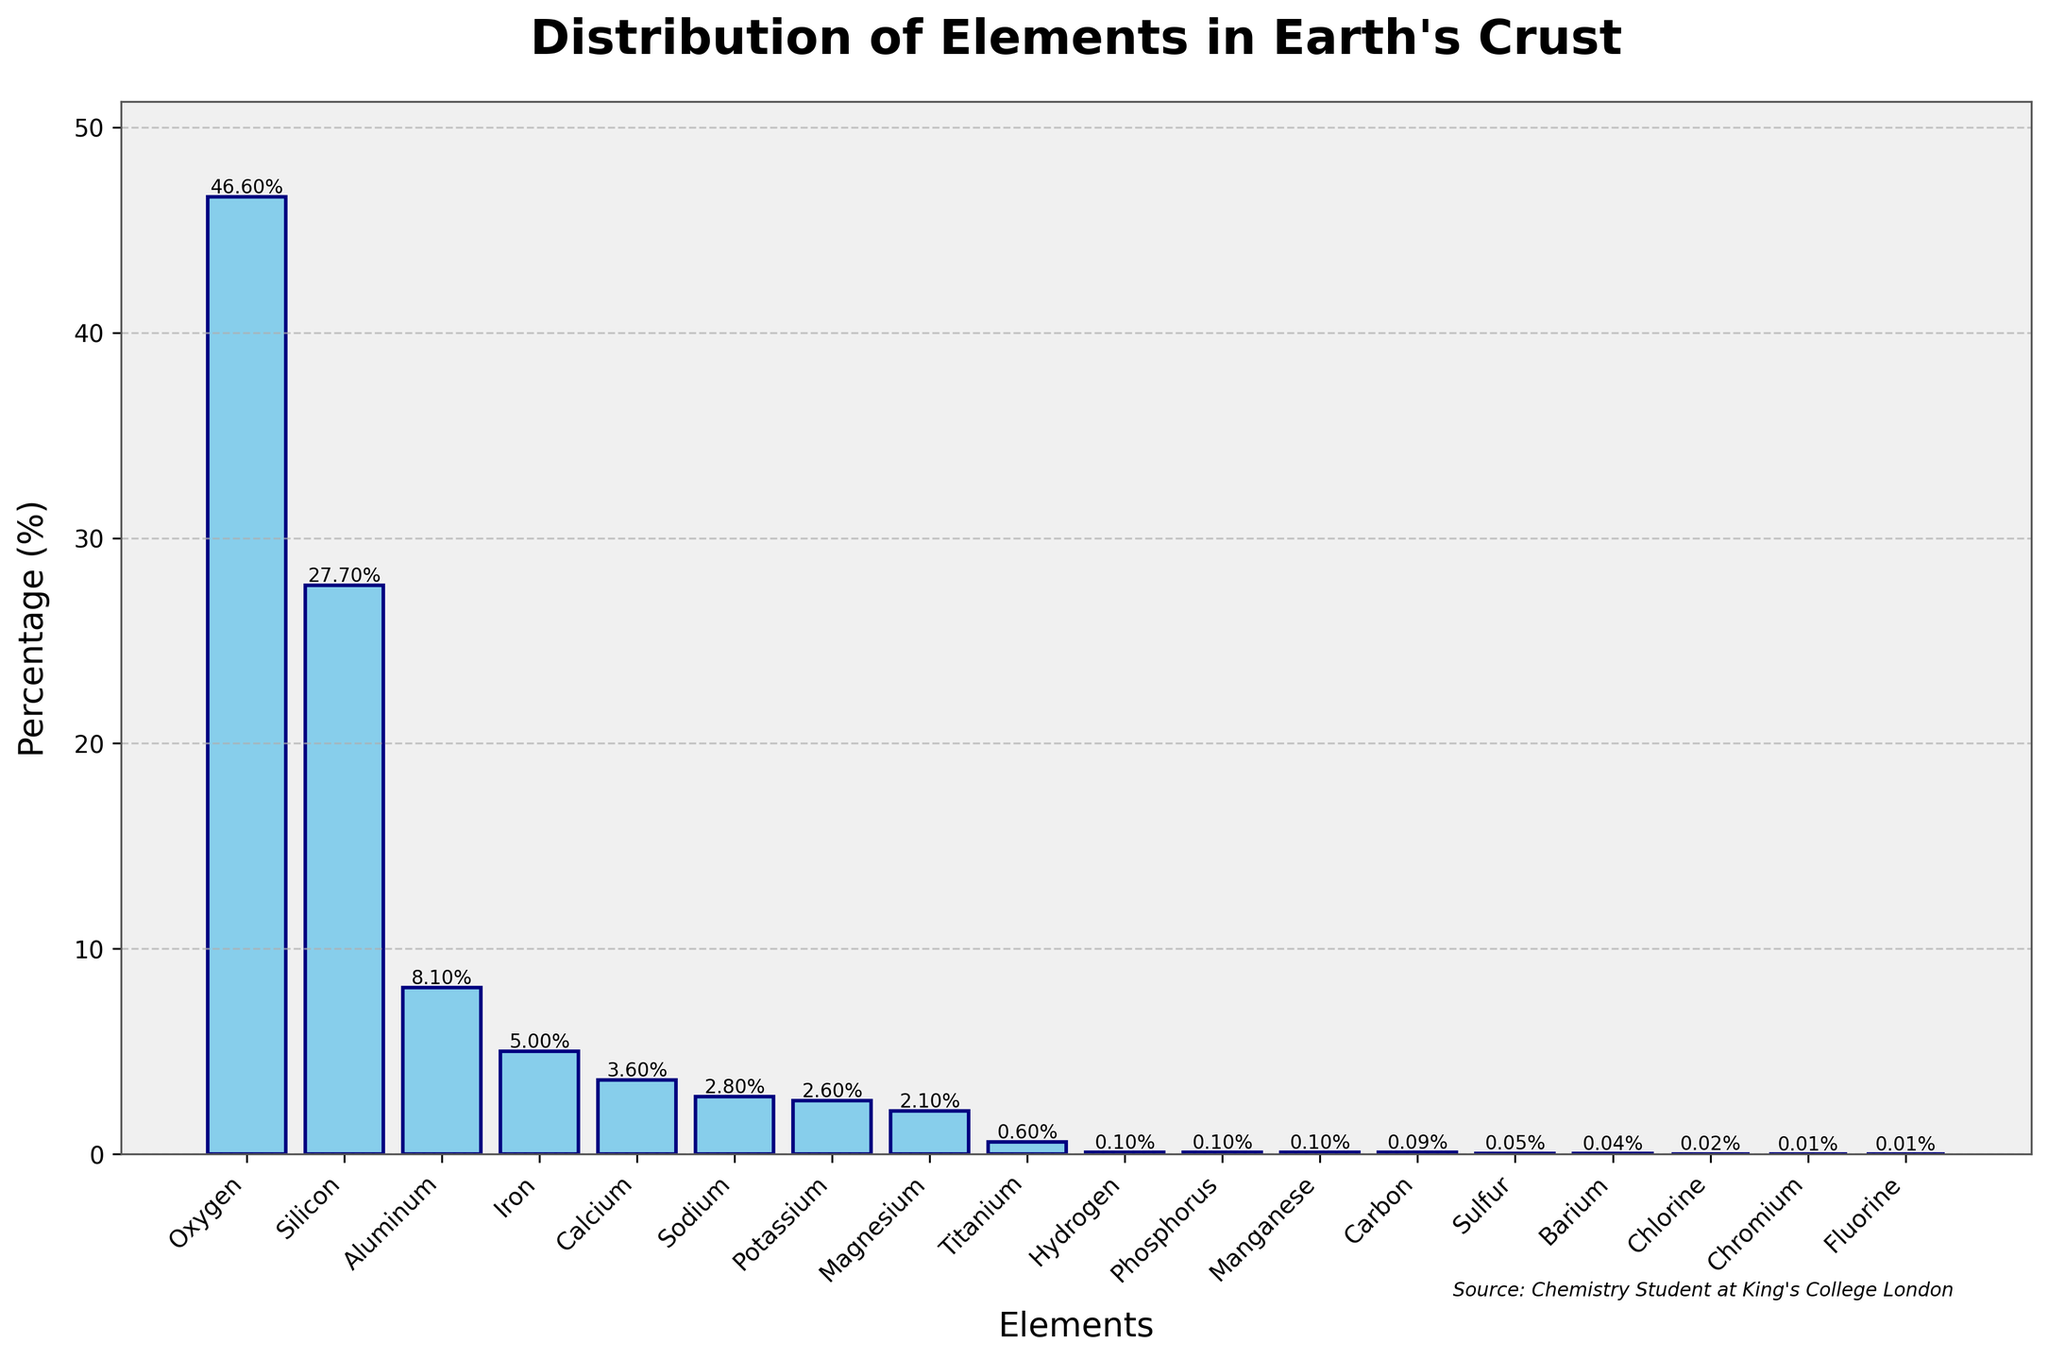Which element has the highest percentage in the Earth's crust? The bar representing Oxygen is the tallest among all, indicating it has the highest percentage.
Answer: Oxygen Which element has a higher percentage: Aluminum or Iron? By comparing the heights of the bars for Aluminum and Iron, the Aluminum bar is taller than the Iron bar.
Answer: Aluminum What is the combined percentage of Oxygen, Silicon, and Aluminum? Add the percentages for Oxygen (46.6), Silicon (27.7), and Aluminum (8.1). The calculation is 46.6 + 27.7 + 8.1 = 82.4.
Answer: 82.4% Is the percentage of Iron greater than the percentage of Calcium? Comparing the heights of the bars for Iron and Calcium, the Iron bar is taller than the Calcium bar.
Answer: Yes Which two elements have the closest percentages in the Earth's crust? Sodium (2.8) and Potassium (2.6) are very close in value.
Answer: Sodium and Potassium What is the difference in percentage between the element with the highest percentage and the element with the second highest percentage? The highest percentage is Oxygen (46.6) and the second highest is Silicon (27.7). The difference is 46.6 - 27.7 = 18.9.
Answer: 18.9 How many elements have a percentage less than 1% in the Earth's crust? By counting the bars with height less than 1%, the elements are Titanium, Hydrogen, Phosphorus, Manganese, Carbon, Sulfur, Barium, Chlorine, Chromium, and Fluorine. There are 10 of them.
Answer: 10 Which element has a percentage closest to 3% in the Earth's crust? By comparison, Calcium at 3.6% is the closest.
Answer: Calcium Are there more elements with a percentage above 2% or below 2% in the Earth's crust? Counting the elements, those above 2% are Oxygen, Silicon, Aluminum, Iron, Calcium, Sodium, and Potassium (7 elements). Those below 2% are Magnesium, Titanium, Hydrogen, Phosphorus, Manganese, Carbon, Sulfur, Barium, Chlorine, Chromium, and Fluorine (11 elements). There are more elements below 2%.
Answer: Below 2% 